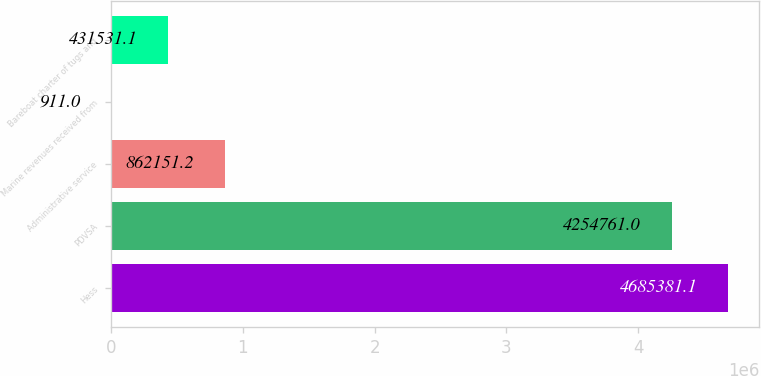Convert chart to OTSL. <chart><loc_0><loc_0><loc_500><loc_500><bar_chart><fcel>Hess<fcel>PDVSA<fcel>Administrative service<fcel>Marine revenues received from<fcel>Bareboat charter of tugs and<nl><fcel>4.68538e+06<fcel>4.25476e+06<fcel>862151<fcel>911<fcel>431531<nl></chart> 